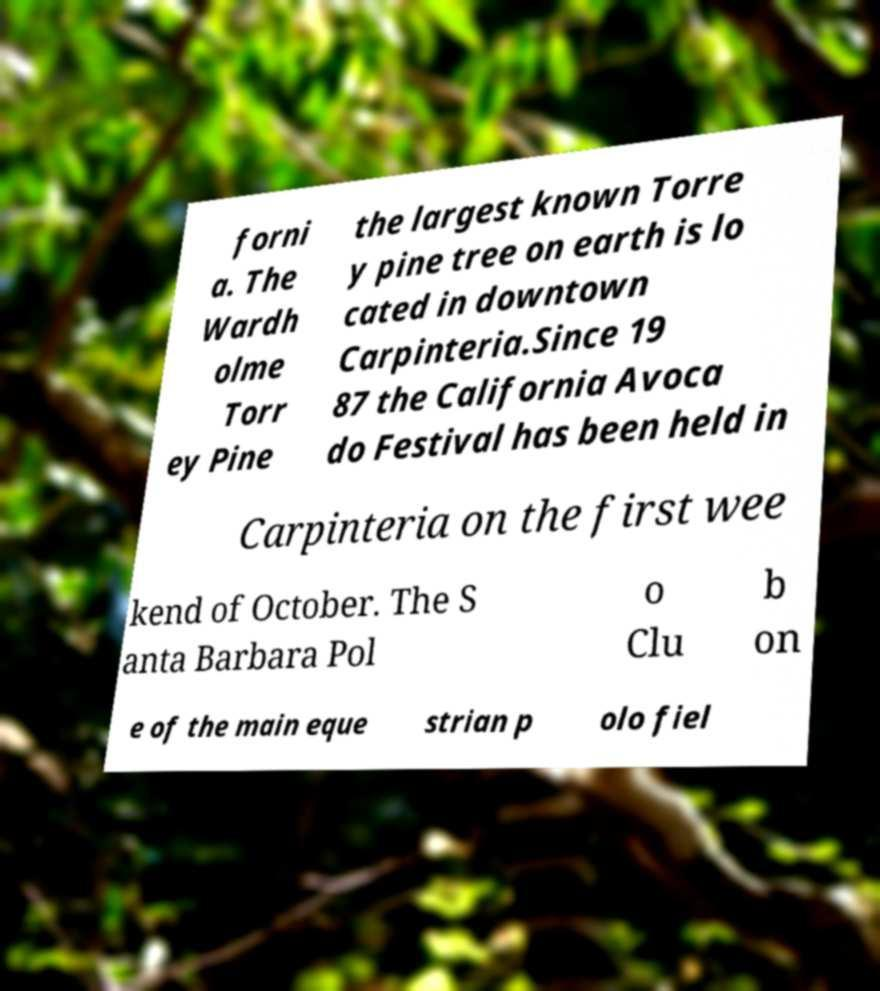I need the written content from this picture converted into text. Can you do that? forni a. The Wardh olme Torr ey Pine the largest known Torre y pine tree on earth is lo cated in downtown Carpinteria.Since 19 87 the California Avoca do Festival has been held in Carpinteria on the first wee kend of October. The S anta Barbara Pol o Clu b on e of the main eque strian p olo fiel 